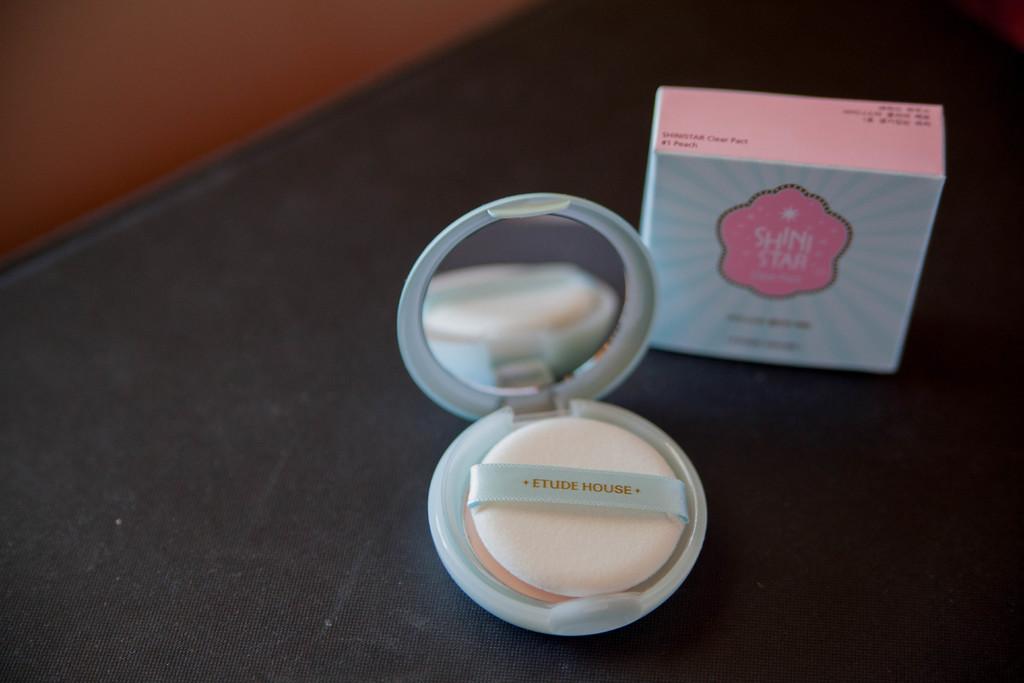Is this makeup?
Your response must be concise. Answering does not require reading text in the image. Women's used this item?
Offer a terse response. Answering does not require reading text in the image. 